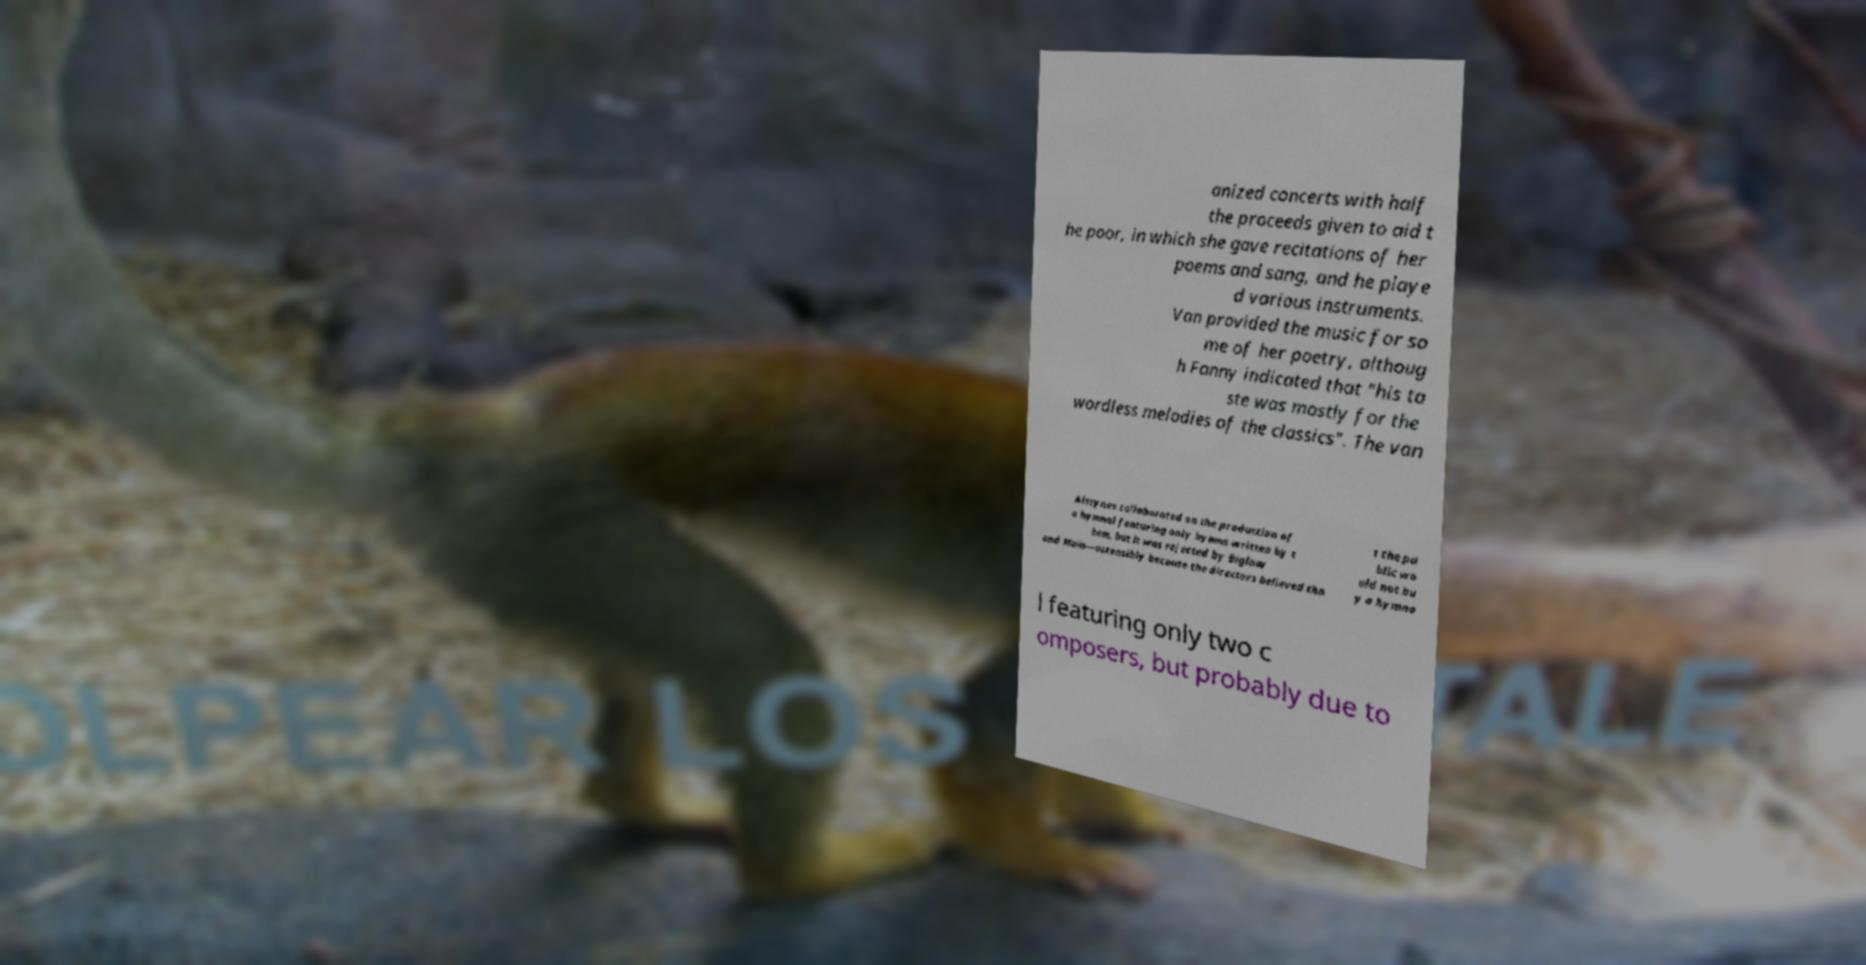Can you accurately transcribe the text from the provided image for me? anized concerts with half the proceeds given to aid t he poor, in which she gave recitations of her poems and sang, and he playe d various instruments. Van provided the music for so me of her poetry, althoug h Fanny indicated that "his ta ste was mostly for the wordless melodies of the classics". The van Alstynes collaborated on the production of a hymnal featuring only hymns written by t hem, but it was rejected by Biglow and Main—ostensibly because the directors believed tha t the pu blic wo uld not bu y a hymna l featuring only two c omposers, but probably due to 